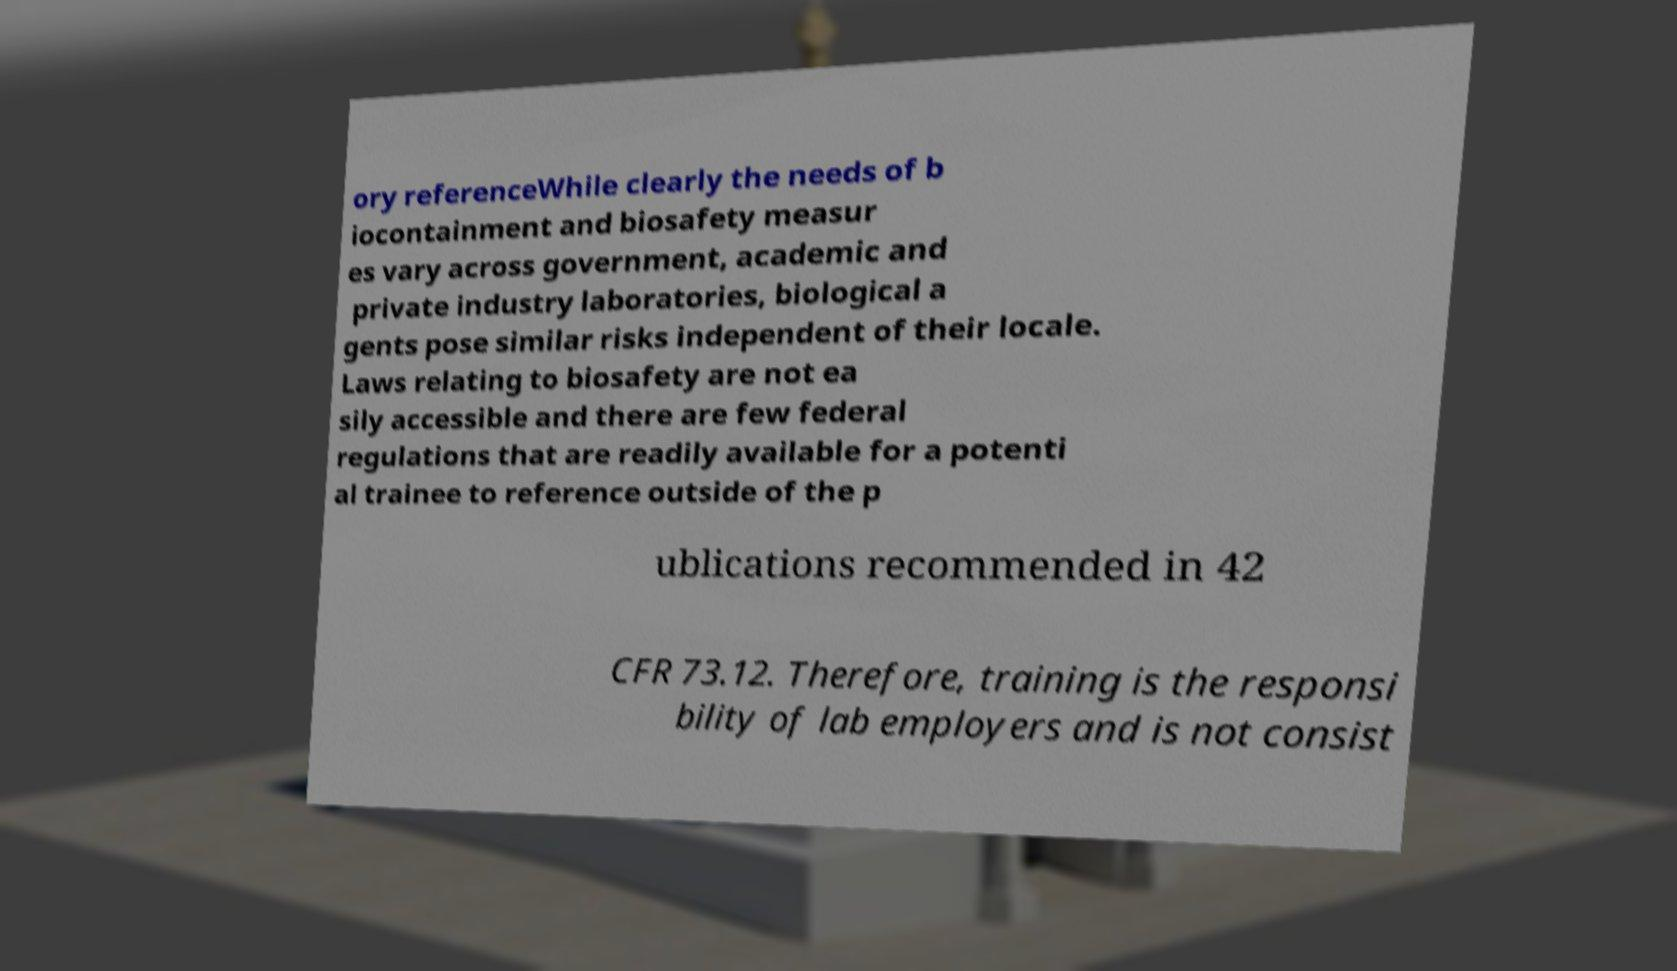There's text embedded in this image that I need extracted. Can you transcribe it verbatim? ory referenceWhile clearly the needs of b iocontainment and biosafety measur es vary across government, academic and private industry laboratories, biological a gents pose similar risks independent of their locale. Laws relating to biosafety are not ea sily accessible and there are few federal regulations that are readily available for a potenti al trainee to reference outside of the p ublications recommended in 42 CFR 73.12. Therefore, training is the responsi bility of lab employers and is not consist 